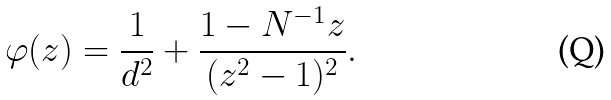<formula> <loc_0><loc_0><loc_500><loc_500>\varphi ( z ) = \frac { 1 } { d ^ { 2 } } + \frac { 1 - N ^ { - 1 } z } { ( z ^ { 2 } - 1 ) ^ { 2 } } .</formula> 